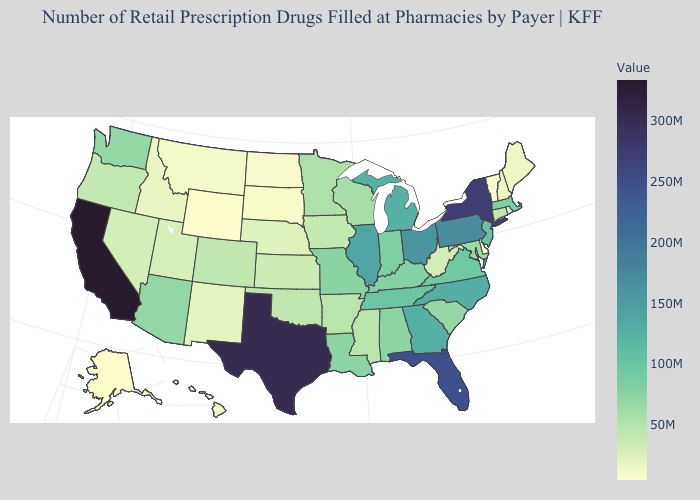Which states have the lowest value in the USA?
Write a very short answer. Alaska. Which states have the highest value in the USA?
Give a very brief answer. California. Does Ohio have the highest value in the MidWest?
Write a very short answer. Yes. Which states have the lowest value in the South?
Short answer required. Delaware. Does California have the highest value in the USA?
Give a very brief answer. Yes. 